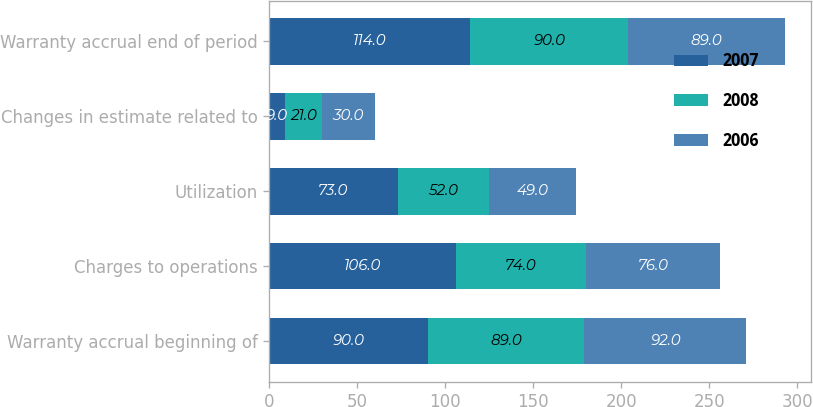Convert chart to OTSL. <chart><loc_0><loc_0><loc_500><loc_500><stacked_bar_chart><ecel><fcel>Warranty accrual beginning of<fcel>Charges to operations<fcel>Utilization<fcel>Changes in estimate related to<fcel>Warranty accrual end of period<nl><fcel>2007<fcel>90<fcel>106<fcel>73<fcel>9<fcel>114<nl><fcel>2008<fcel>89<fcel>74<fcel>52<fcel>21<fcel>90<nl><fcel>2006<fcel>92<fcel>76<fcel>49<fcel>30<fcel>89<nl></chart> 